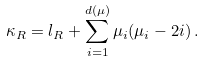Convert formula to latex. <formula><loc_0><loc_0><loc_500><loc_500>\kappa _ { R } = l _ { R } + \sum _ { i = 1 } ^ { d ( \mu ) } \mu _ { i } ( \mu _ { i } - 2 i ) \, .</formula> 